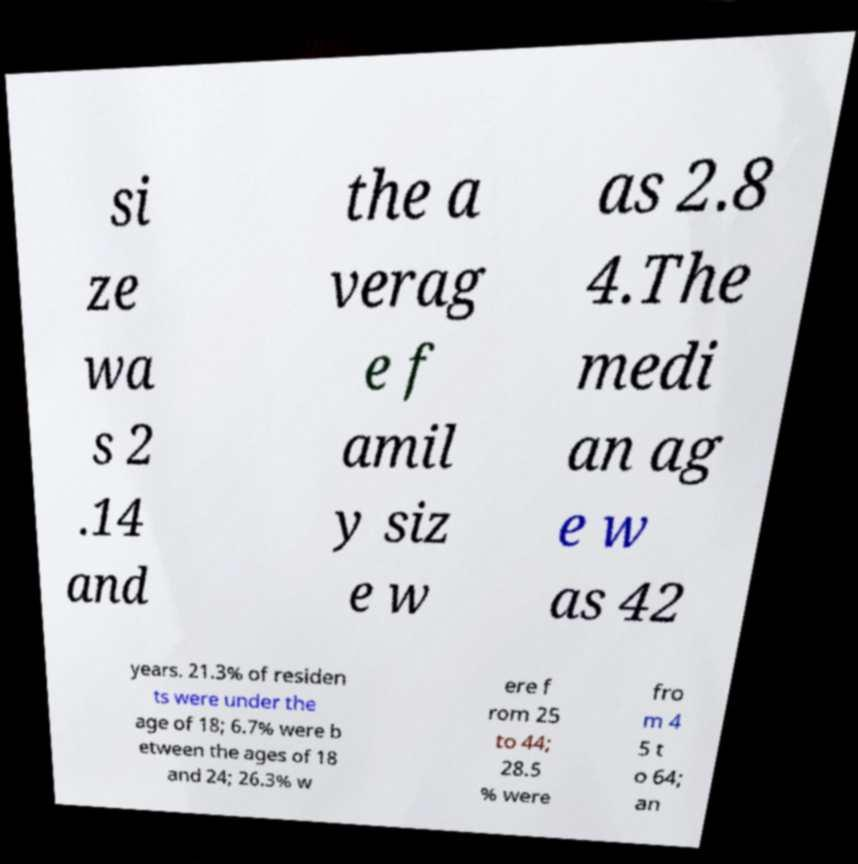Could you assist in decoding the text presented in this image and type it out clearly? si ze wa s 2 .14 and the a verag e f amil y siz e w as 2.8 4.The medi an ag e w as 42 years. 21.3% of residen ts were under the age of 18; 6.7% were b etween the ages of 18 and 24; 26.3% w ere f rom 25 to 44; 28.5 % were fro m 4 5 t o 64; an 